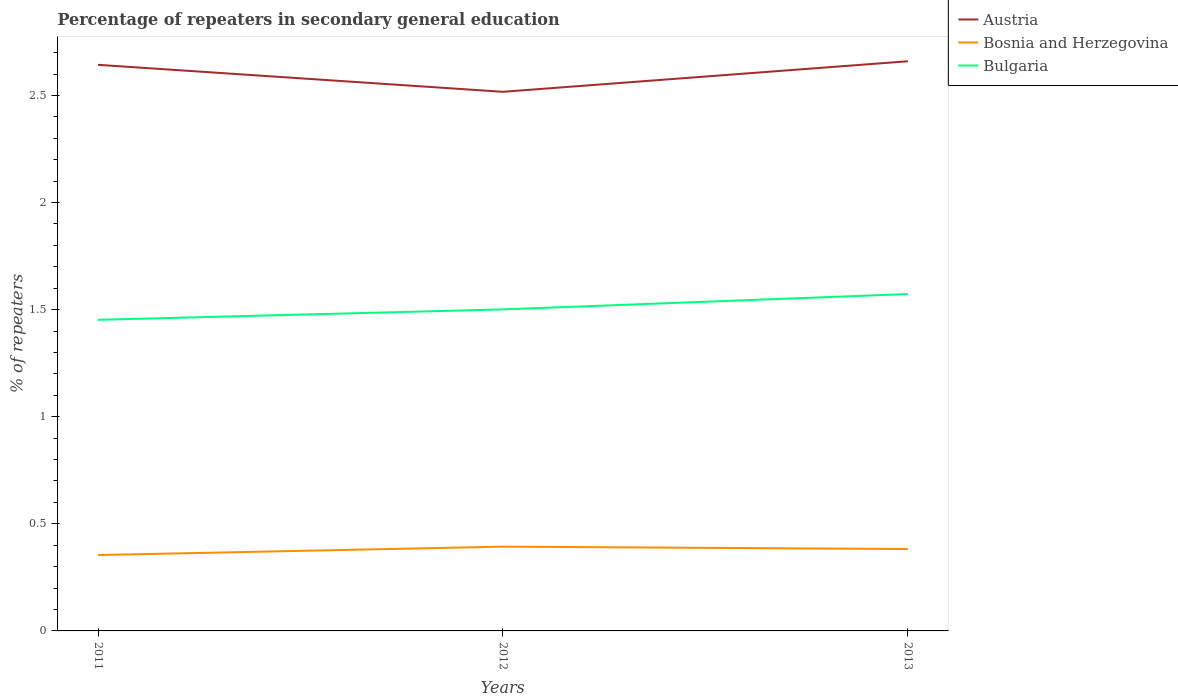How many different coloured lines are there?
Give a very brief answer. 3. Does the line corresponding to Bosnia and Herzegovina intersect with the line corresponding to Austria?
Your answer should be very brief. No. Across all years, what is the maximum percentage of repeaters in secondary general education in Austria?
Make the answer very short. 2.52. What is the total percentage of repeaters in secondary general education in Bulgaria in the graph?
Offer a very short reply. -0.05. What is the difference between the highest and the second highest percentage of repeaters in secondary general education in Bosnia and Herzegovina?
Offer a terse response. 0.04. What is the difference between the highest and the lowest percentage of repeaters in secondary general education in Bulgaria?
Provide a succinct answer. 1. Are the values on the major ticks of Y-axis written in scientific E-notation?
Offer a very short reply. No. Does the graph contain any zero values?
Give a very brief answer. No. Where does the legend appear in the graph?
Make the answer very short. Top right. How are the legend labels stacked?
Provide a succinct answer. Vertical. What is the title of the graph?
Provide a short and direct response. Percentage of repeaters in secondary general education. Does "Kenya" appear as one of the legend labels in the graph?
Ensure brevity in your answer.  No. What is the label or title of the Y-axis?
Give a very brief answer. % of repeaters. What is the % of repeaters of Austria in 2011?
Your answer should be very brief. 2.64. What is the % of repeaters of Bosnia and Herzegovina in 2011?
Keep it short and to the point. 0.35. What is the % of repeaters in Bulgaria in 2011?
Give a very brief answer. 1.45. What is the % of repeaters of Austria in 2012?
Ensure brevity in your answer.  2.52. What is the % of repeaters in Bosnia and Herzegovina in 2012?
Keep it short and to the point. 0.39. What is the % of repeaters in Bulgaria in 2012?
Make the answer very short. 1.5. What is the % of repeaters of Austria in 2013?
Keep it short and to the point. 2.66. What is the % of repeaters in Bosnia and Herzegovina in 2013?
Provide a succinct answer. 0.38. What is the % of repeaters of Bulgaria in 2013?
Your response must be concise. 1.57. Across all years, what is the maximum % of repeaters of Austria?
Provide a short and direct response. 2.66. Across all years, what is the maximum % of repeaters in Bosnia and Herzegovina?
Your answer should be very brief. 0.39. Across all years, what is the maximum % of repeaters in Bulgaria?
Keep it short and to the point. 1.57. Across all years, what is the minimum % of repeaters of Austria?
Keep it short and to the point. 2.52. Across all years, what is the minimum % of repeaters of Bosnia and Herzegovina?
Your response must be concise. 0.35. Across all years, what is the minimum % of repeaters in Bulgaria?
Ensure brevity in your answer.  1.45. What is the total % of repeaters of Austria in the graph?
Give a very brief answer. 7.82. What is the total % of repeaters in Bosnia and Herzegovina in the graph?
Your response must be concise. 1.13. What is the total % of repeaters in Bulgaria in the graph?
Offer a terse response. 4.53. What is the difference between the % of repeaters of Austria in 2011 and that in 2012?
Ensure brevity in your answer.  0.13. What is the difference between the % of repeaters in Bosnia and Herzegovina in 2011 and that in 2012?
Make the answer very short. -0.04. What is the difference between the % of repeaters of Bulgaria in 2011 and that in 2012?
Make the answer very short. -0.05. What is the difference between the % of repeaters in Austria in 2011 and that in 2013?
Keep it short and to the point. -0.02. What is the difference between the % of repeaters of Bosnia and Herzegovina in 2011 and that in 2013?
Provide a short and direct response. -0.03. What is the difference between the % of repeaters in Bulgaria in 2011 and that in 2013?
Your answer should be very brief. -0.12. What is the difference between the % of repeaters in Austria in 2012 and that in 2013?
Provide a short and direct response. -0.14. What is the difference between the % of repeaters of Bosnia and Herzegovina in 2012 and that in 2013?
Your answer should be very brief. 0.01. What is the difference between the % of repeaters in Bulgaria in 2012 and that in 2013?
Make the answer very short. -0.07. What is the difference between the % of repeaters in Austria in 2011 and the % of repeaters in Bosnia and Herzegovina in 2012?
Provide a succinct answer. 2.25. What is the difference between the % of repeaters of Austria in 2011 and the % of repeaters of Bulgaria in 2012?
Offer a very short reply. 1.14. What is the difference between the % of repeaters in Bosnia and Herzegovina in 2011 and the % of repeaters in Bulgaria in 2012?
Your response must be concise. -1.15. What is the difference between the % of repeaters of Austria in 2011 and the % of repeaters of Bosnia and Herzegovina in 2013?
Give a very brief answer. 2.26. What is the difference between the % of repeaters in Austria in 2011 and the % of repeaters in Bulgaria in 2013?
Give a very brief answer. 1.07. What is the difference between the % of repeaters in Bosnia and Herzegovina in 2011 and the % of repeaters in Bulgaria in 2013?
Give a very brief answer. -1.22. What is the difference between the % of repeaters of Austria in 2012 and the % of repeaters of Bosnia and Herzegovina in 2013?
Your answer should be compact. 2.13. What is the difference between the % of repeaters in Austria in 2012 and the % of repeaters in Bulgaria in 2013?
Keep it short and to the point. 0.94. What is the difference between the % of repeaters of Bosnia and Herzegovina in 2012 and the % of repeaters of Bulgaria in 2013?
Your answer should be very brief. -1.18. What is the average % of repeaters in Austria per year?
Your answer should be very brief. 2.61. What is the average % of repeaters in Bosnia and Herzegovina per year?
Make the answer very short. 0.38. What is the average % of repeaters in Bulgaria per year?
Your answer should be compact. 1.51. In the year 2011, what is the difference between the % of repeaters in Austria and % of repeaters in Bosnia and Herzegovina?
Provide a succinct answer. 2.29. In the year 2011, what is the difference between the % of repeaters of Austria and % of repeaters of Bulgaria?
Your answer should be very brief. 1.19. In the year 2011, what is the difference between the % of repeaters in Bosnia and Herzegovina and % of repeaters in Bulgaria?
Your answer should be very brief. -1.1. In the year 2012, what is the difference between the % of repeaters in Austria and % of repeaters in Bosnia and Herzegovina?
Keep it short and to the point. 2.12. In the year 2012, what is the difference between the % of repeaters in Austria and % of repeaters in Bulgaria?
Offer a very short reply. 1.02. In the year 2012, what is the difference between the % of repeaters in Bosnia and Herzegovina and % of repeaters in Bulgaria?
Give a very brief answer. -1.11. In the year 2013, what is the difference between the % of repeaters of Austria and % of repeaters of Bosnia and Herzegovina?
Make the answer very short. 2.28. In the year 2013, what is the difference between the % of repeaters of Austria and % of repeaters of Bulgaria?
Give a very brief answer. 1.09. In the year 2013, what is the difference between the % of repeaters in Bosnia and Herzegovina and % of repeaters in Bulgaria?
Your answer should be compact. -1.19. What is the ratio of the % of repeaters of Bosnia and Herzegovina in 2011 to that in 2012?
Ensure brevity in your answer.  0.9. What is the ratio of the % of repeaters of Bulgaria in 2011 to that in 2012?
Offer a very short reply. 0.97. What is the ratio of the % of repeaters of Bosnia and Herzegovina in 2011 to that in 2013?
Your response must be concise. 0.93. What is the ratio of the % of repeaters in Bulgaria in 2011 to that in 2013?
Your answer should be very brief. 0.92. What is the ratio of the % of repeaters of Austria in 2012 to that in 2013?
Provide a short and direct response. 0.95. What is the ratio of the % of repeaters of Bosnia and Herzegovina in 2012 to that in 2013?
Your answer should be compact. 1.03. What is the ratio of the % of repeaters of Bulgaria in 2012 to that in 2013?
Your answer should be compact. 0.95. What is the difference between the highest and the second highest % of repeaters in Austria?
Give a very brief answer. 0.02. What is the difference between the highest and the second highest % of repeaters in Bosnia and Herzegovina?
Your response must be concise. 0.01. What is the difference between the highest and the second highest % of repeaters of Bulgaria?
Your response must be concise. 0.07. What is the difference between the highest and the lowest % of repeaters of Austria?
Ensure brevity in your answer.  0.14. What is the difference between the highest and the lowest % of repeaters of Bosnia and Herzegovina?
Offer a terse response. 0.04. What is the difference between the highest and the lowest % of repeaters of Bulgaria?
Your answer should be compact. 0.12. 